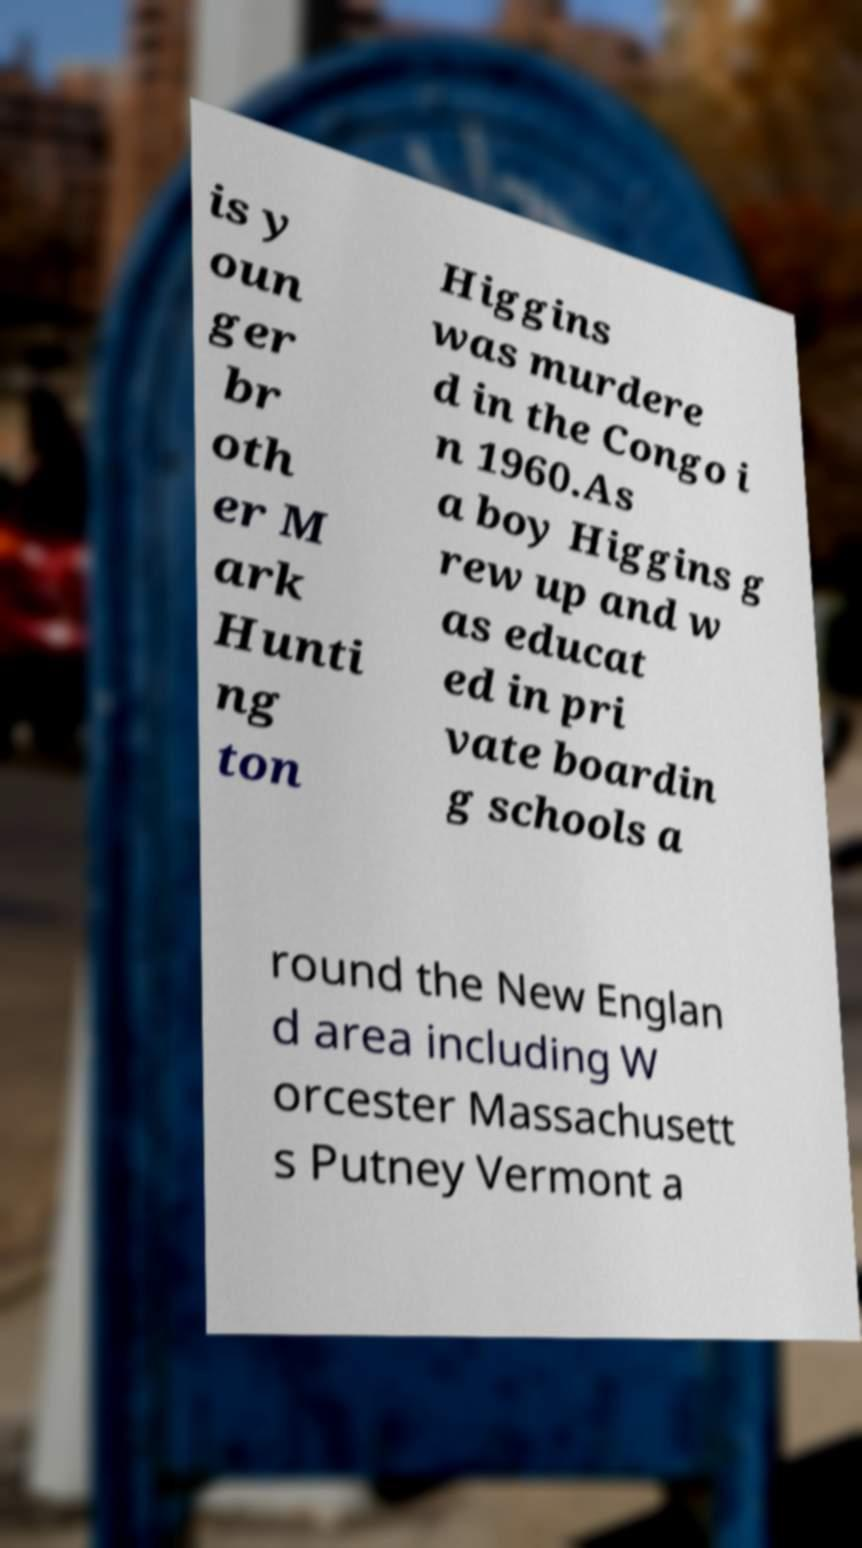Please read and relay the text visible in this image. What does it say? is y oun ger br oth er M ark Hunti ng ton Higgins was murdere d in the Congo i n 1960.As a boy Higgins g rew up and w as educat ed in pri vate boardin g schools a round the New Englan d area including W orcester Massachusett s Putney Vermont a 